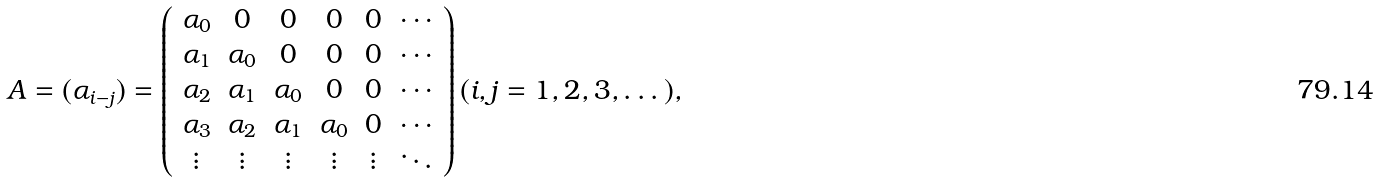Convert formula to latex. <formula><loc_0><loc_0><loc_500><loc_500>A = ( \alpha _ { i - j } ) = \left ( \begin{array} { c c c c c c } \alpha _ { 0 } & 0 & 0 & 0 & 0 & \cdots \\ \alpha _ { 1 } & \alpha _ { 0 } & 0 & 0 & 0 & \cdots \\ \alpha _ { 2 } & \alpha _ { 1 } & \alpha _ { 0 } & 0 & 0 & \cdots \\ \alpha _ { 3 } & \alpha _ { 2 } & \alpha _ { 1 } & \alpha _ { 0 } & 0 & \cdots \\ \vdots & \vdots & \vdots & \vdots & \vdots & \ddots \end{array} \right ) ( i , j = 1 , 2 , 3 , \dots ) ,</formula> 